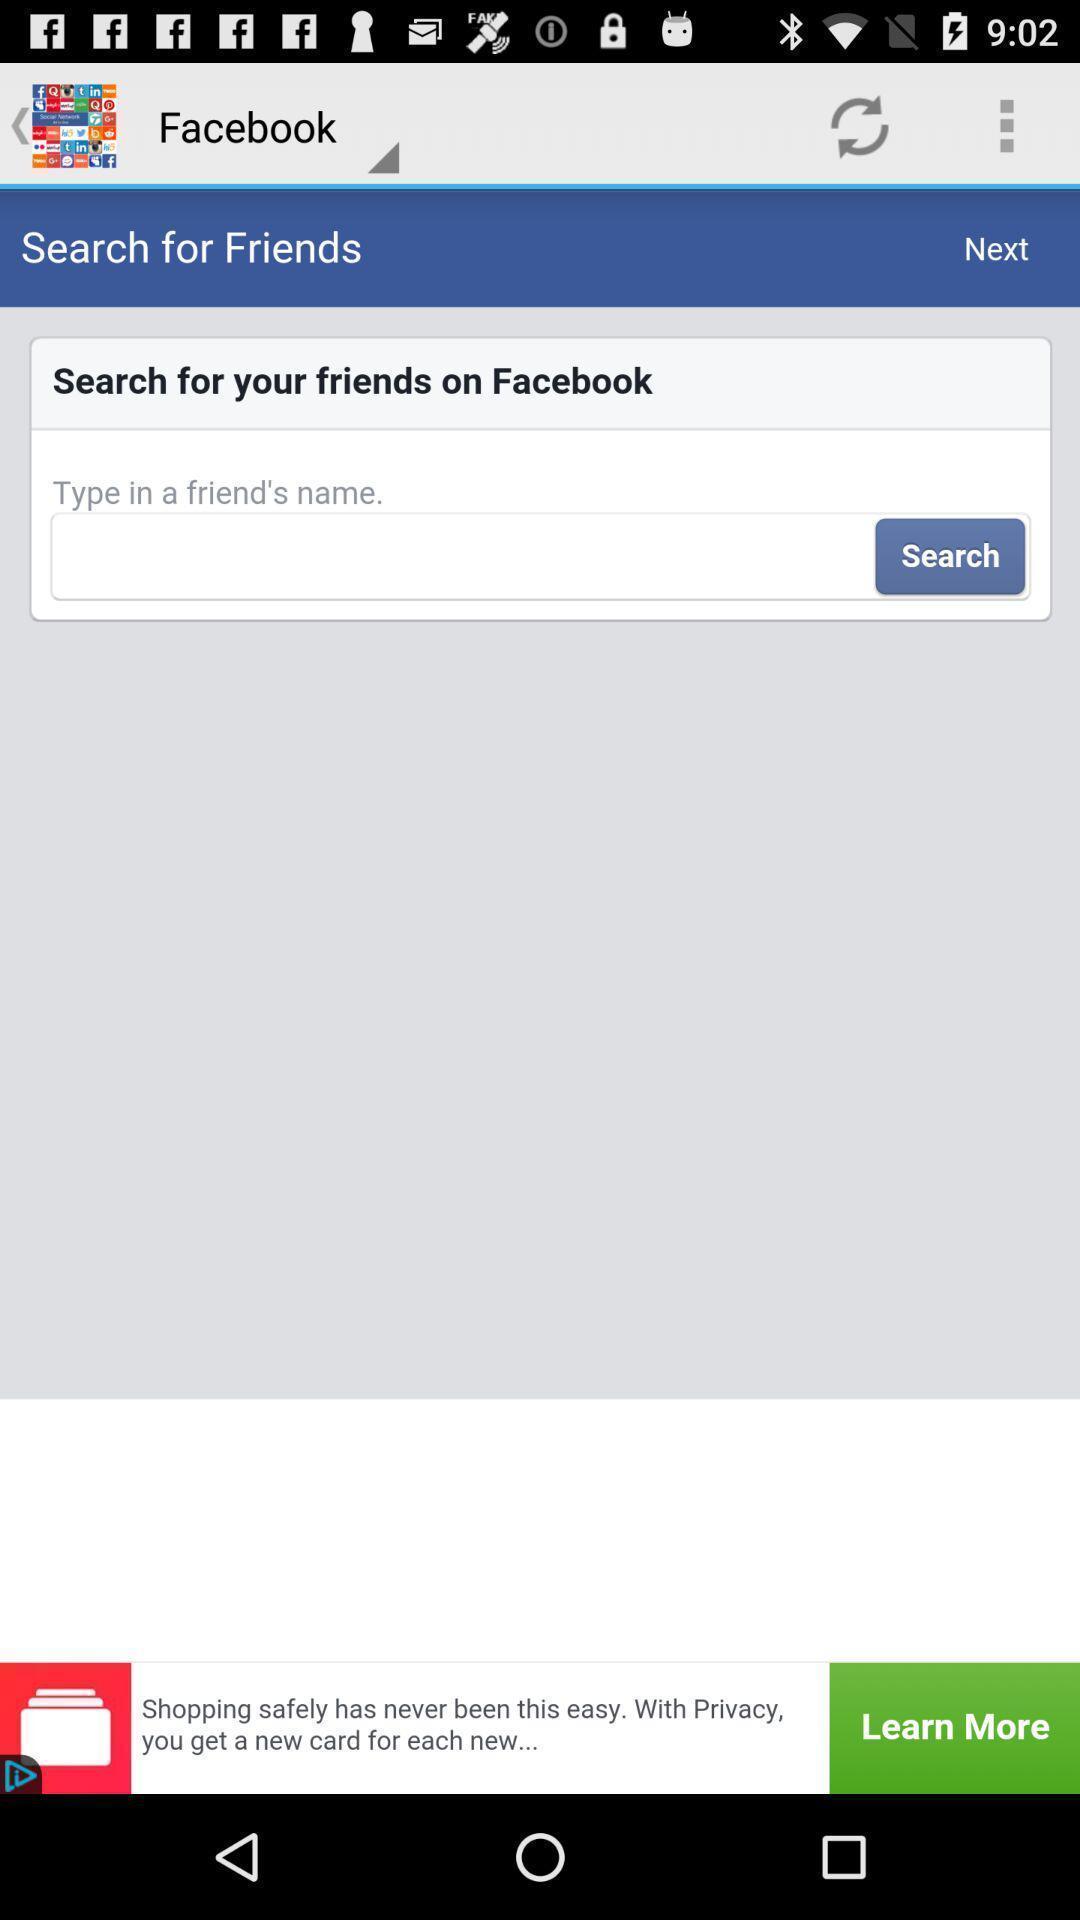What details can you identify in this image? Search for friends in the social app. 